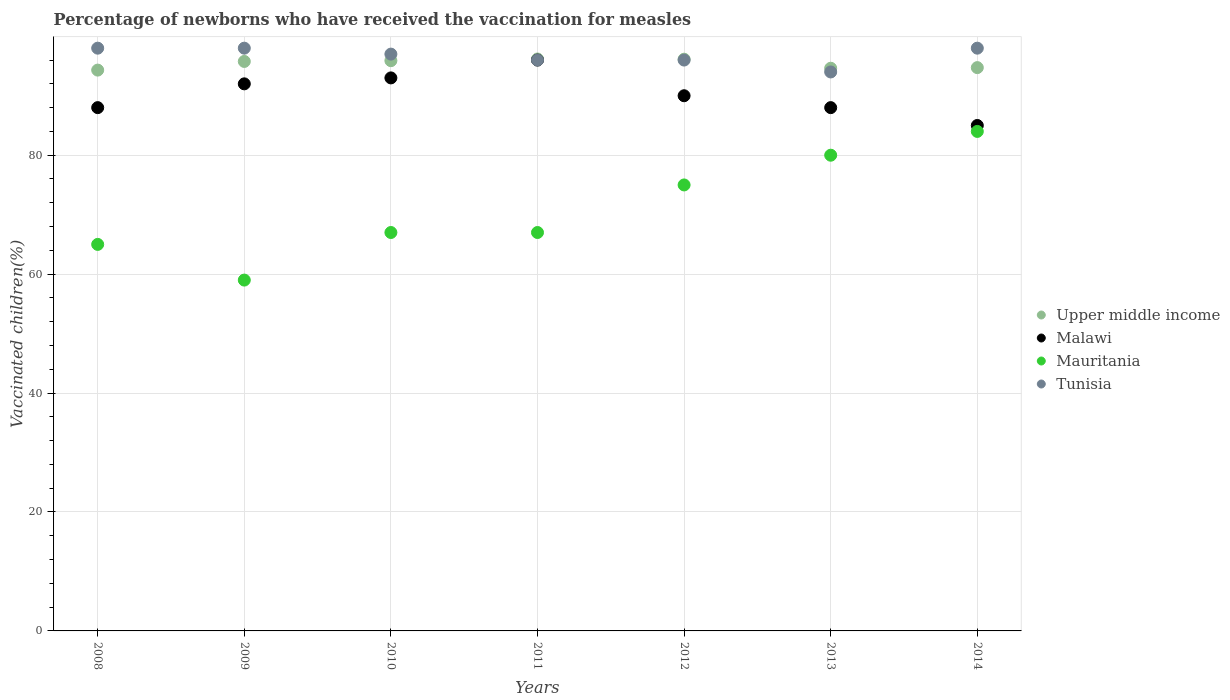Is the number of dotlines equal to the number of legend labels?
Your response must be concise. Yes. Across all years, what is the maximum percentage of vaccinated children in Upper middle income?
Give a very brief answer. 96.18. Across all years, what is the minimum percentage of vaccinated children in Tunisia?
Provide a succinct answer. 94. In which year was the percentage of vaccinated children in Upper middle income maximum?
Your answer should be compact. 2011. In which year was the percentage of vaccinated children in Malawi minimum?
Keep it short and to the point. 2014. What is the total percentage of vaccinated children in Malawi in the graph?
Give a very brief answer. 632. What is the difference between the percentage of vaccinated children in Upper middle income in 2011 and the percentage of vaccinated children in Tunisia in 2010?
Offer a terse response. -0.82. What is the average percentage of vaccinated children in Upper middle income per year?
Your response must be concise. 95.38. In the year 2012, what is the difference between the percentage of vaccinated children in Mauritania and percentage of vaccinated children in Upper middle income?
Provide a short and direct response. -21.15. What is the ratio of the percentage of vaccinated children in Malawi in 2011 to that in 2012?
Give a very brief answer. 1.07. Is the difference between the percentage of vaccinated children in Mauritania in 2008 and 2011 greater than the difference between the percentage of vaccinated children in Upper middle income in 2008 and 2011?
Your response must be concise. No. What is the difference between the highest and the second highest percentage of vaccinated children in Mauritania?
Your response must be concise. 4. What is the difference between the highest and the lowest percentage of vaccinated children in Malawi?
Offer a very short reply. 11. Is the sum of the percentage of vaccinated children in Upper middle income in 2011 and 2012 greater than the maximum percentage of vaccinated children in Malawi across all years?
Keep it short and to the point. Yes. Is it the case that in every year, the sum of the percentage of vaccinated children in Upper middle income and percentage of vaccinated children in Malawi  is greater than the percentage of vaccinated children in Mauritania?
Provide a succinct answer. Yes. Is the percentage of vaccinated children in Tunisia strictly greater than the percentage of vaccinated children in Upper middle income over the years?
Give a very brief answer. No. Is the percentage of vaccinated children in Malawi strictly less than the percentage of vaccinated children in Upper middle income over the years?
Give a very brief answer. Yes. How many years are there in the graph?
Your answer should be very brief. 7. Does the graph contain any zero values?
Your answer should be compact. No. Where does the legend appear in the graph?
Make the answer very short. Center right. How many legend labels are there?
Provide a succinct answer. 4. How are the legend labels stacked?
Provide a succinct answer. Vertical. What is the title of the graph?
Your answer should be very brief. Percentage of newborns who have received the vaccination for measles. What is the label or title of the X-axis?
Offer a terse response. Years. What is the label or title of the Y-axis?
Offer a terse response. Vaccinated children(%). What is the Vaccinated children(%) in Upper middle income in 2008?
Your response must be concise. 94.31. What is the Vaccinated children(%) of Malawi in 2008?
Provide a succinct answer. 88. What is the Vaccinated children(%) in Tunisia in 2008?
Your answer should be compact. 98. What is the Vaccinated children(%) in Upper middle income in 2009?
Your response must be concise. 95.77. What is the Vaccinated children(%) of Malawi in 2009?
Your answer should be very brief. 92. What is the Vaccinated children(%) in Mauritania in 2009?
Keep it short and to the point. 59. What is the Vaccinated children(%) of Upper middle income in 2010?
Keep it short and to the point. 95.9. What is the Vaccinated children(%) of Malawi in 2010?
Ensure brevity in your answer.  93. What is the Vaccinated children(%) of Mauritania in 2010?
Offer a terse response. 67. What is the Vaccinated children(%) of Tunisia in 2010?
Offer a terse response. 97. What is the Vaccinated children(%) in Upper middle income in 2011?
Provide a short and direct response. 96.18. What is the Vaccinated children(%) of Malawi in 2011?
Make the answer very short. 96. What is the Vaccinated children(%) of Tunisia in 2011?
Ensure brevity in your answer.  96. What is the Vaccinated children(%) in Upper middle income in 2012?
Ensure brevity in your answer.  96.15. What is the Vaccinated children(%) in Malawi in 2012?
Keep it short and to the point. 90. What is the Vaccinated children(%) of Mauritania in 2012?
Offer a very short reply. 75. What is the Vaccinated children(%) in Tunisia in 2012?
Provide a succinct answer. 96. What is the Vaccinated children(%) in Upper middle income in 2013?
Your answer should be compact. 94.63. What is the Vaccinated children(%) of Malawi in 2013?
Your answer should be compact. 88. What is the Vaccinated children(%) of Tunisia in 2013?
Offer a terse response. 94. What is the Vaccinated children(%) in Upper middle income in 2014?
Keep it short and to the point. 94.73. What is the Vaccinated children(%) in Malawi in 2014?
Provide a short and direct response. 85. Across all years, what is the maximum Vaccinated children(%) in Upper middle income?
Ensure brevity in your answer.  96.18. Across all years, what is the maximum Vaccinated children(%) of Malawi?
Your answer should be very brief. 96. Across all years, what is the maximum Vaccinated children(%) of Mauritania?
Your response must be concise. 84. Across all years, what is the maximum Vaccinated children(%) of Tunisia?
Your answer should be compact. 98. Across all years, what is the minimum Vaccinated children(%) of Upper middle income?
Your answer should be very brief. 94.31. Across all years, what is the minimum Vaccinated children(%) of Mauritania?
Offer a very short reply. 59. Across all years, what is the minimum Vaccinated children(%) in Tunisia?
Provide a succinct answer. 94. What is the total Vaccinated children(%) in Upper middle income in the graph?
Offer a very short reply. 667.66. What is the total Vaccinated children(%) in Malawi in the graph?
Your answer should be compact. 632. What is the total Vaccinated children(%) of Mauritania in the graph?
Provide a succinct answer. 497. What is the total Vaccinated children(%) in Tunisia in the graph?
Make the answer very short. 677. What is the difference between the Vaccinated children(%) of Upper middle income in 2008 and that in 2009?
Offer a very short reply. -1.46. What is the difference between the Vaccinated children(%) of Malawi in 2008 and that in 2009?
Provide a short and direct response. -4. What is the difference between the Vaccinated children(%) of Tunisia in 2008 and that in 2009?
Keep it short and to the point. 0. What is the difference between the Vaccinated children(%) in Upper middle income in 2008 and that in 2010?
Make the answer very short. -1.58. What is the difference between the Vaccinated children(%) of Tunisia in 2008 and that in 2010?
Your answer should be very brief. 1. What is the difference between the Vaccinated children(%) in Upper middle income in 2008 and that in 2011?
Ensure brevity in your answer.  -1.87. What is the difference between the Vaccinated children(%) of Malawi in 2008 and that in 2011?
Your answer should be compact. -8. What is the difference between the Vaccinated children(%) of Upper middle income in 2008 and that in 2012?
Offer a terse response. -1.83. What is the difference between the Vaccinated children(%) of Upper middle income in 2008 and that in 2013?
Ensure brevity in your answer.  -0.31. What is the difference between the Vaccinated children(%) of Malawi in 2008 and that in 2013?
Keep it short and to the point. 0. What is the difference between the Vaccinated children(%) in Mauritania in 2008 and that in 2013?
Offer a very short reply. -15. What is the difference between the Vaccinated children(%) in Upper middle income in 2008 and that in 2014?
Keep it short and to the point. -0.42. What is the difference between the Vaccinated children(%) of Malawi in 2008 and that in 2014?
Your answer should be compact. 3. What is the difference between the Vaccinated children(%) of Tunisia in 2008 and that in 2014?
Make the answer very short. 0. What is the difference between the Vaccinated children(%) in Upper middle income in 2009 and that in 2010?
Give a very brief answer. -0.13. What is the difference between the Vaccinated children(%) in Malawi in 2009 and that in 2010?
Provide a short and direct response. -1. What is the difference between the Vaccinated children(%) of Mauritania in 2009 and that in 2010?
Your response must be concise. -8. What is the difference between the Vaccinated children(%) in Tunisia in 2009 and that in 2010?
Provide a succinct answer. 1. What is the difference between the Vaccinated children(%) of Upper middle income in 2009 and that in 2011?
Offer a terse response. -0.41. What is the difference between the Vaccinated children(%) in Mauritania in 2009 and that in 2011?
Provide a succinct answer. -8. What is the difference between the Vaccinated children(%) of Tunisia in 2009 and that in 2011?
Ensure brevity in your answer.  2. What is the difference between the Vaccinated children(%) of Upper middle income in 2009 and that in 2012?
Offer a terse response. -0.38. What is the difference between the Vaccinated children(%) in Tunisia in 2009 and that in 2012?
Offer a terse response. 2. What is the difference between the Vaccinated children(%) of Upper middle income in 2009 and that in 2013?
Your answer should be very brief. 1.14. What is the difference between the Vaccinated children(%) of Malawi in 2009 and that in 2013?
Give a very brief answer. 4. What is the difference between the Vaccinated children(%) in Tunisia in 2009 and that in 2013?
Keep it short and to the point. 4. What is the difference between the Vaccinated children(%) in Upper middle income in 2009 and that in 2014?
Keep it short and to the point. 1.04. What is the difference between the Vaccinated children(%) of Malawi in 2009 and that in 2014?
Your response must be concise. 7. What is the difference between the Vaccinated children(%) of Mauritania in 2009 and that in 2014?
Give a very brief answer. -25. What is the difference between the Vaccinated children(%) in Upper middle income in 2010 and that in 2011?
Make the answer very short. -0.28. What is the difference between the Vaccinated children(%) of Malawi in 2010 and that in 2011?
Offer a very short reply. -3. What is the difference between the Vaccinated children(%) in Mauritania in 2010 and that in 2011?
Ensure brevity in your answer.  0. What is the difference between the Vaccinated children(%) of Upper middle income in 2010 and that in 2012?
Provide a short and direct response. -0.25. What is the difference between the Vaccinated children(%) in Malawi in 2010 and that in 2012?
Offer a terse response. 3. What is the difference between the Vaccinated children(%) in Upper middle income in 2010 and that in 2013?
Offer a terse response. 1.27. What is the difference between the Vaccinated children(%) of Tunisia in 2010 and that in 2013?
Your response must be concise. 3. What is the difference between the Vaccinated children(%) in Upper middle income in 2010 and that in 2014?
Ensure brevity in your answer.  1.17. What is the difference between the Vaccinated children(%) of Malawi in 2010 and that in 2014?
Offer a terse response. 8. What is the difference between the Vaccinated children(%) in Mauritania in 2010 and that in 2014?
Keep it short and to the point. -17. What is the difference between the Vaccinated children(%) of Tunisia in 2010 and that in 2014?
Provide a short and direct response. -1. What is the difference between the Vaccinated children(%) of Upper middle income in 2011 and that in 2012?
Ensure brevity in your answer.  0.03. What is the difference between the Vaccinated children(%) of Malawi in 2011 and that in 2012?
Offer a very short reply. 6. What is the difference between the Vaccinated children(%) of Upper middle income in 2011 and that in 2013?
Give a very brief answer. 1.55. What is the difference between the Vaccinated children(%) in Mauritania in 2011 and that in 2013?
Your answer should be very brief. -13. What is the difference between the Vaccinated children(%) of Upper middle income in 2011 and that in 2014?
Offer a terse response. 1.45. What is the difference between the Vaccinated children(%) of Malawi in 2011 and that in 2014?
Offer a very short reply. 11. What is the difference between the Vaccinated children(%) in Mauritania in 2011 and that in 2014?
Your answer should be compact. -17. What is the difference between the Vaccinated children(%) of Tunisia in 2011 and that in 2014?
Your answer should be compact. -2. What is the difference between the Vaccinated children(%) in Upper middle income in 2012 and that in 2013?
Provide a short and direct response. 1.52. What is the difference between the Vaccinated children(%) of Malawi in 2012 and that in 2013?
Provide a short and direct response. 2. What is the difference between the Vaccinated children(%) of Mauritania in 2012 and that in 2013?
Keep it short and to the point. -5. What is the difference between the Vaccinated children(%) of Tunisia in 2012 and that in 2013?
Offer a terse response. 2. What is the difference between the Vaccinated children(%) of Upper middle income in 2012 and that in 2014?
Your answer should be compact. 1.41. What is the difference between the Vaccinated children(%) in Tunisia in 2012 and that in 2014?
Your answer should be compact. -2. What is the difference between the Vaccinated children(%) of Upper middle income in 2013 and that in 2014?
Ensure brevity in your answer.  -0.11. What is the difference between the Vaccinated children(%) of Malawi in 2013 and that in 2014?
Your answer should be very brief. 3. What is the difference between the Vaccinated children(%) of Mauritania in 2013 and that in 2014?
Ensure brevity in your answer.  -4. What is the difference between the Vaccinated children(%) in Upper middle income in 2008 and the Vaccinated children(%) in Malawi in 2009?
Offer a very short reply. 2.31. What is the difference between the Vaccinated children(%) in Upper middle income in 2008 and the Vaccinated children(%) in Mauritania in 2009?
Provide a succinct answer. 35.31. What is the difference between the Vaccinated children(%) in Upper middle income in 2008 and the Vaccinated children(%) in Tunisia in 2009?
Provide a succinct answer. -3.69. What is the difference between the Vaccinated children(%) in Malawi in 2008 and the Vaccinated children(%) in Tunisia in 2009?
Make the answer very short. -10. What is the difference between the Vaccinated children(%) in Mauritania in 2008 and the Vaccinated children(%) in Tunisia in 2009?
Keep it short and to the point. -33. What is the difference between the Vaccinated children(%) in Upper middle income in 2008 and the Vaccinated children(%) in Malawi in 2010?
Make the answer very short. 1.31. What is the difference between the Vaccinated children(%) of Upper middle income in 2008 and the Vaccinated children(%) of Mauritania in 2010?
Your response must be concise. 27.31. What is the difference between the Vaccinated children(%) in Upper middle income in 2008 and the Vaccinated children(%) in Tunisia in 2010?
Your answer should be compact. -2.69. What is the difference between the Vaccinated children(%) of Malawi in 2008 and the Vaccinated children(%) of Mauritania in 2010?
Your answer should be very brief. 21. What is the difference between the Vaccinated children(%) in Mauritania in 2008 and the Vaccinated children(%) in Tunisia in 2010?
Ensure brevity in your answer.  -32. What is the difference between the Vaccinated children(%) of Upper middle income in 2008 and the Vaccinated children(%) of Malawi in 2011?
Your answer should be compact. -1.69. What is the difference between the Vaccinated children(%) of Upper middle income in 2008 and the Vaccinated children(%) of Mauritania in 2011?
Offer a terse response. 27.31. What is the difference between the Vaccinated children(%) of Upper middle income in 2008 and the Vaccinated children(%) of Tunisia in 2011?
Ensure brevity in your answer.  -1.69. What is the difference between the Vaccinated children(%) of Malawi in 2008 and the Vaccinated children(%) of Mauritania in 2011?
Your response must be concise. 21. What is the difference between the Vaccinated children(%) of Malawi in 2008 and the Vaccinated children(%) of Tunisia in 2011?
Provide a succinct answer. -8. What is the difference between the Vaccinated children(%) of Mauritania in 2008 and the Vaccinated children(%) of Tunisia in 2011?
Your answer should be very brief. -31. What is the difference between the Vaccinated children(%) of Upper middle income in 2008 and the Vaccinated children(%) of Malawi in 2012?
Keep it short and to the point. 4.31. What is the difference between the Vaccinated children(%) of Upper middle income in 2008 and the Vaccinated children(%) of Mauritania in 2012?
Ensure brevity in your answer.  19.31. What is the difference between the Vaccinated children(%) of Upper middle income in 2008 and the Vaccinated children(%) of Tunisia in 2012?
Provide a short and direct response. -1.69. What is the difference between the Vaccinated children(%) of Malawi in 2008 and the Vaccinated children(%) of Mauritania in 2012?
Offer a terse response. 13. What is the difference between the Vaccinated children(%) of Mauritania in 2008 and the Vaccinated children(%) of Tunisia in 2012?
Provide a succinct answer. -31. What is the difference between the Vaccinated children(%) in Upper middle income in 2008 and the Vaccinated children(%) in Malawi in 2013?
Your answer should be very brief. 6.31. What is the difference between the Vaccinated children(%) in Upper middle income in 2008 and the Vaccinated children(%) in Mauritania in 2013?
Offer a terse response. 14.31. What is the difference between the Vaccinated children(%) of Upper middle income in 2008 and the Vaccinated children(%) of Tunisia in 2013?
Make the answer very short. 0.31. What is the difference between the Vaccinated children(%) of Malawi in 2008 and the Vaccinated children(%) of Mauritania in 2013?
Provide a short and direct response. 8. What is the difference between the Vaccinated children(%) in Malawi in 2008 and the Vaccinated children(%) in Tunisia in 2013?
Your answer should be very brief. -6. What is the difference between the Vaccinated children(%) of Upper middle income in 2008 and the Vaccinated children(%) of Malawi in 2014?
Keep it short and to the point. 9.31. What is the difference between the Vaccinated children(%) in Upper middle income in 2008 and the Vaccinated children(%) in Mauritania in 2014?
Keep it short and to the point. 10.31. What is the difference between the Vaccinated children(%) of Upper middle income in 2008 and the Vaccinated children(%) of Tunisia in 2014?
Make the answer very short. -3.69. What is the difference between the Vaccinated children(%) in Malawi in 2008 and the Vaccinated children(%) in Tunisia in 2014?
Provide a short and direct response. -10. What is the difference between the Vaccinated children(%) in Mauritania in 2008 and the Vaccinated children(%) in Tunisia in 2014?
Keep it short and to the point. -33. What is the difference between the Vaccinated children(%) of Upper middle income in 2009 and the Vaccinated children(%) of Malawi in 2010?
Your response must be concise. 2.77. What is the difference between the Vaccinated children(%) in Upper middle income in 2009 and the Vaccinated children(%) in Mauritania in 2010?
Ensure brevity in your answer.  28.77. What is the difference between the Vaccinated children(%) of Upper middle income in 2009 and the Vaccinated children(%) of Tunisia in 2010?
Make the answer very short. -1.23. What is the difference between the Vaccinated children(%) in Mauritania in 2009 and the Vaccinated children(%) in Tunisia in 2010?
Provide a short and direct response. -38. What is the difference between the Vaccinated children(%) of Upper middle income in 2009 and the Vaccinated children(%) of Malawi in 2011?
Provide a short and direct response. -0.23. What is the difference between the Vaccinated children(%) in Upper middle income in 2009 and the Vaccinated children(%) in Mauritania in 2011?
Make the answer very short. 28.77. What is the difference between the Vaccinated children(%) of Upper middle income in 2009 and the Vaccinated children(%) of Tunisia in 2011?
Provide a succinct answer. -0.23. What is the difference between the Vaccinated children(%) of Malawi in 2009 and the Vaccinated children(%) of Mauritania in 2011?
Keep it short and to the point. 25. What is the difference between the Vaccinated children(%) in Malawi in 2009 and the Vaccinated children(%) in Tunisia in 2011?
Provide a succinct answer. -4. What is the difference between the Vaccinated children(%) in Mauritania in 2009 and the Vaccinated children(%) in Tunisia in 2011?
Offer a terse response. -37. What is the difference between the Vaccinated children(%) of Upper middle income in 2009 and the Vaccinated children(%) of Malawi in 2012?
Offer a very short reply. 5.77. What is the difference between the Vaccinated children(%) in Upper middle income in 2009 and the Vaccinated children(%) in Mauritania in 2012?
Provide a succinct answer. 20.77. What is the difference between the Vaccinated children(%) in Upper middle income in 2009 and the Vaccinated children(%) in Tunisia in 2012?
Your answer should be very brief. -0.23. What is the difference between the Vaccinated children(%) in Malawi in 2009 and the Vaccinated children(%) in Mauritania in 2012?
Your answer should be compact. 17. What is the difference between the Vaccinated children(%) of Mauritania in 2009 and the Vaccinated children(%) of Tunisia in 2012?
Your answer should be compact. -37. What is the difference between the Vaccinated children(%) in Upper middle income in 2009 and the Vaccinated children(%) in Malawi in 2013?
Your answer should be compact. 7.77. What is the difference between the Vaccinated children(%) of Upper middle income in 2009 and the Vaccinated children(%) of Mauritania in 2013?
Keep it short and to the point. 15.77. What is the difference between the Vaccinated children(%) in Upper middle income in 2009 and the Vaccinated children(%) in Tunisia in 2013?
Ensure brevity in your answer.  1.77. What is the difference between the Vaccinated children(%) of Malawi in 2009 and the Vaccinated children(%) of Mauritania in 2013?
Ensure brevity in your answer.  12. What is the difference between the Vaccinated children(%) of Malawi in 2009 and the Vaccinated children(%) of Tunisia in 2013?
Offer a very short reply. -2. What is the difference between the Vaccinated children(%) of Mauritania in 2009 and the Vaccinated children(%) of Tunisia in 2013?
Offer a very short reply. -35. What is the difference between the Vaccinated children(%) in Upper middle income in 2009 and the Vaccinated children(%) in Malawi in 2014?
Your response must be concise. 10.77. What is the difference between the Vaccinated children(%) of Upper middle income in 2009 and the Vaccinated children(%) of Mauritania in 2014?
Provide a short and direct response. 11.77. What is the difference between the Vaccinated children(%) in Upper middle income in 2009 and the Vaccinated children(%) in Tunisia in 2014?
Your response must be concise. -2.23. What is the difference between the Vaccinated children(%) in Malawi in 2009 and the Vaccinated children(%) in Tunisia in 2014?
Keep it short and to the point. -6. What is the difference between the Vaccinated children(%) of Mauritania in 2009 and the Vaccinated children(%) of Tunisia in 2014?
Make the answer very short. -39. What is the difference between the Vaccinated children(%) in Upper middle income in 2010 and the Vaccinated children(%) in Malawi in 2011?
Offer a very short reply. -0.1. What is the difference between the Vaccinated children(%) in Upper middle income in 2010 and the Vaccinated children(%) in Mauritania in 2011?
Your response must be concise. 28.9. What is the difference between the Vaccinated children(%) of Upper middle income in 2010 and the Vaccinated children(%) of Tunisia in 2011?
Offer a very short reply. -0.1. What is the difference between the Vaccinated children(%) in Upper middle income in 2010 and the Vaccinated children(%) in Malawi in 2012?
Your response must be concise. 5.9. What is the difference between the Vaccinated children(%) of Upper middle income in 2010 and the Vaccinated children(%) of Mauritania in 2012?
Your answer should be compact. 20.9. What is the difference between the Vaccinated children(%) in Upper middle income in 2010 and the Vaccinated children(%) in Tunisia in 2012?
Make the answer very short. -0.1. What is the difference between the Vaccinated children(%) of Malawi in 2010 and the Vaccinated children(%) of Tunisia in 2012?
Your response must be concise. -3. What is the difference between the Vaccinated children(%) of Mauritania in 2010 and the Vaccinated children(%) of Tunisia in 2012?
Keep it short and to the point. -29. What is the difference between the Vaccinated children(%) in Upper middle income in 2010 and the Vaccinated children(%) in Malawi in 2013?
Give a very brief answer. 7.9. What is the difference between the Vaccinated children(%) in Upper middle income in 2010 and the Vaccinated children(%) in Mauritania in 2013?
Ensure brevity in your answer.  15.9. What is the difference between the Vaccinated children(%) in Upper middle income in 2010 and the Vaccinated children(%) in Tunisia in 2013?
Offer a terse response. 1.9. What is the difference between the Vaccinated children(%) in Malawi in 2010 and the Vaccinated children(%) in Mauritania in 2013?
Offer a terse response. 13. What is the difference between the Vaccinated children(%) in Upper middle income in 2010 and the Vaccinated children(%) in Malawi in 2014?
Your answer should be compact. 10.9. What is the difference between the Vaccinated children(%) in Upper middle income in 2010 and the Vaccinated children(%) in Mauritania in 2014?
Provide a short and direct response. 11.9. What is the difference between the Vaccinated children(%) of Upper middle income in 2010 and the Vaccinated children(%) of Tunisia in 2014?
Provide a short and direct response. -2.1. What is the difference between the Vaccinated children(%) of Malawi in 2010 and the Vaccinated children(%) of Tunisia in 2014?
Make the answer very short. -5. What is the difference between the Vaccinated children(%) of Mauritania in 2010 and the Vaccinated children(%) of Tunisia in 2014?
Provide a succinct answer. -31. What is the difference between the Vaccinated children(%) of Upper middle income in 2011 and the Vaccinated children(%) of Malawi in 2012?
Make the answer very short. 6.18. What is the difference between the Vaccinated children(%) in Upper middle income in 2011 and the Vaccinated children(%) in Mauritania in 2012?
Your answer should be compact. 21.18. What is the difference between the Vaccinated children(%) of Upper middle income in 2011 and the Vaccinated children(%) of Tunisia in 2012?
Your answer should be compact. 0.18. What is the difference between the Vaccinated children(%) of Malawi in 2011 and the Vaccinated children(%) of Mauritania in 2012?
Your answer should be very brief. 21. What is the difference between the Vaccinated children(%) of Malawi in 2011 and the Vaccinated children(%) of Tunisia in 2012?
Offer a terse response. 0. What is the difference between the Vaccinated children(%) in Mauritania in 2011 and the Vaccinated children(%) in Tunisia in 2012?
Your answer should be compact. -29. What is the difference between the Vaccinated children(%) of Upper middle income in 2011 and the Vaccinated children(%) of Malawi in 2013?
Provide a succinct answer. 8.18. What is the difference between the Vaccinated children(%) of Upper middle income in 2011 and the Vaccinated children(%) of Mauritania in 2013?
Keep it short and to the point. 16.18. What is the difference between the Vaccinated children(%) of Upper middle income in 2011 and the Vaccinated children(%) of Tunisia in 2013?
Your answer should be compact. 2.18. What is the difference between the Vaccinated children(%) of Malawi in 2011 and the Vaccinated children(%) of Mauritania in 2013?
Offer a terse response. 16. What is the difference between the Vaccinated children(%) of Mauritania in 2011 and the Vaccinated children(%) of Tunisia in 2013?
Your response must be concise. -27. What is the difference between the Vaccinated children(%) of Upper middle income in 2011 and the Vaccinated children(%) of Malawi in 2014?
Make the answer very short. 11.18. What is the difference between the Vaccinated children(%) in Upper middle income in 2011 and the Vaccinated children(%) in Mauritania in 2014?
Your response must be concise. 12.18. What is the difference between the Vaccinated children(%) in Upper middle income in 2011 and the Vaccinated children(%) in Tunisia in 2014?
Make the answer very short. -1.82. What is the difference between the Vaccinated children(%) in Malawi in 2011 and the Vaccinated children(%) in Tunisia in 2014?
Keep it short and to the point. -2. What is the difference between the Vaccinated children(%) in Mauritania in 2011 and the Vaccinated children(%) in Tunisia in 2014?
Keep it short and to the point. -31. What is the difference between the Vaccinated children(%) in Upper middle income in 2012 and the Vaccinated children(%) in Malawi in 2013?
Keep it short and to the point. 8.15. What is the difference between the Vaccinated children(%) in Upper middle income in 2012 and the Vaccinated children(%) in Mauritania in 2013?
Offer a very short reply. 16.15. What is the difference between the Vaccinated children(%) in Upper middle income in 2012 and the Vaccinated children(%) in Tunisia in 2013?
Your answer should be very brief. 2.15. What is the difference between the Vaccinated children(%) in Malawi in 2012 and the Vaccinated children(%) in Mauritania in 2013?
Ensure brevity in your answer.  10. What is the difference between the Vaccinated children(%) in Upper middle income in 2012 and the Vaccinated children(%) in Malawi in 2014?
Make the answer very short. 11.15. What is the difference between the Vaccinated children(%) in Upper middle income in 2012 and the Vaccinated children(%) in Mauritania in 2014?
Provide a succinct answer. 12.15. What is the difference between the Vaccinated children(%) of Upper middle income in 2012 and the Vaccinated children(%) of Tunisia in 2014?
Provide a short and direct response. -1.85. What is the difference between the Vaccinated children(%) of Malawi in 2012 and the Vaccinated children(%) of Tunisia in 2014?
Provide a short and direct response. -8. What is the difference between the Vaccinated children(%) of Mauritania in 2012 and the Vaccinated children(%) of Tunisia in 2014?
Keep it short and to the point. -23. What is the difference between the Vaccinated children(%) in Upper middle income in 2013 and the Vaccinated children(%) in Malawi in 2014?
Your answer should be very brief. 9.63. What is the difference between the Vaccinated children(%) in Upper middle income in 2013 and the Vaccinated children(%) in Mauritania in 2014?
Your answer should be very brief. 10.63. What is the difference between the Vaccinated children(%) of Upper middle income in 2013 and the Vaccinated children(%) of Tunisia in 2014?
Your answer should be compact. -3.37. What is the average Vaccinated children(%) in Upper middle income per year?
Ensure brevity in your answer.  95.38. What is the average Vaccinated children(%) in Malawi per year?
Your answer should be very brief. 90.29. What is the average Vaccinated children(%) of Mauritania per year?
Provide a short and direct response. 71. What is the average Vaccinated children(%) in Tunisia per year?
Your response must be concise. 96.71. In the year 2008, what is the difference between the Vaccinated children(%) of Upper middle income and Vaccinated children(%) of Malawi?
Your answer should be compact. 6.31. In the year 2008, what is the difference between the Vaccinated children(%) of Upper middle income and Vaccinated children(%) of Mauritania?
Offer a very short reply. 29.31. In the year 2008, what is the difference between the Vaccinated children(%) in Upper middle income and Vaccinated children(%) in Tunisia?
Offer a terse response. -3.69. In the year 2008, what is the difference between the Vaccinated children(%) in Malawi and Vaccinated children(%) in Mauritania?
Ensure brevity in your answer.  23. In the year 2008, what is the difference between the Vaccinated children(%) in Malawi and Vaccinated children(%) in Tunisia?
Ensure brevity in your answer.  -10. In the year 2008, what is the difference between the Vaccinated children(%) of Mauritania and Vaccinated children(%) of Tunisia?
Provide a succinct answer. -33. In the year 2009, what is the difference between the Vaccinated children(%) of Upper middle income and Vaccinated children(%) of Malawi?
Your response must be concise. 3.77. In the year 2009, what is the difference between the Vaccinated children(%) of Upper middle income and Vaccinated children(%) of Mauritania?
Your response must be concise. 36.77. In the year 2009, what is the difference between the Vaccinated children(%) in Upper middle income and Vaccinated children(%) in Tunisia?
Your answer should be compact. -2.23. In the year 2009, what is the difference between the Vaccinated children(%) in Malawi and Vaccinated children(%) in Mauritania?
Offer a terse response. 33. In the year 2009, what is the difference between the Vaccinated children(%) in Mauritania and Vaccinated children(%) in Tunisia?
Offer a terse response. -39. In the year 2010, what is the difference between the Vaccinated children(%) of Upper middle income and Vaccinated children(%) of Malawi?
Your response must be concise. 2.9. In the year 2010, what is the difference between the Vaccinated children(%) in Upper middle income and Vaccinated children(%) in Mauritania?
Keep it short and to the point. 28.9. In the year 2010, what is the difference between the Vaccinated children(%) in Upper middle income and Vaccinated children(%) in Tunisia?
Give a very brief answer. -1.1. In the year 2010, what is the difference between the Vaccinated children(%) in Malawi and Vaccinated children(%) in Mauritania?
Offer a very short reply. 26. In the year 2010, what is the difference between the Vaccinated children(%) of Malawi and Vaccinated children(%) of Tunisia?
Offer a very short reply. -4. In the year 2010, what is the difference between the Vaccinated children(%) in Mauritania and Vaccinated children(%) in Tunisia?
Provide a short and direct response. -30. In the year 2011, what is the difference between the Vaccinated children(%) of Upper middle income and Vaccinated children(%) of Malawi?
Your response must be concise. 0.18. In the year 2011, what is the difference between the Vaccinated children(%) in Upper middle income and Vaccinated children(%) in Mauritania?
Your answer should be very brief. 29.18. In the year 2011, what is the difference between the Vaccinated children(%) of Upper middle income and Vaccinated children(%) of Tunisia?
Offer a terse response. 0.18. In the year 2011, what is the difference between the Vaccinated children(%) of Malawi and Vaccinated children(%) of Tunisia?
Provide a short and direct response. 0. In the year 2012, what is the difference between the Vaccinated children(%) of Upper middle income and Vaccinated children(%) of Malawi?
Offer a very short reply. 6.15. In the year 2012, what is the difference between the Vaccinated children(%) in Upper middle income and Vaccinated children(%) in Mauritania?
Keep it short and to the point. 21.15. In the year 2012, what is the difference between the Vaccinated children(%) in Upper middle income and Vaccinated children(%) in Tunisia?
Keep it short and to the point. 0.15. In the year 2012, what is the difference between the Vaccinated children(%) in Mauritania and Vaccinated children(%) in Tunisia?
Your answer should be compact. -21. In the year 2013, what is the difference between the Vaccinated children(%) of Upper middle income and Vaccinated children(%) of Malawi?
Provide a short and direct response. 6.63. In the year 2013, what is the difference between the Vaccinated children(%) in Upper middle income and Vaccinated children(%) in Mauritania?
Your answer should be very brief. 14.63. In the year 2013, what is the difference between the Vaccinated children(%) in Upper middle income and Vaccinated children(%) in Tunisia?
Make the answer very short. 0.63. In the year 2014, what is the difference between the Vaccinated children(%) in Upper middle income and Vaccinated children(%) in Malawi?
Give a very brief answer. 9.73. In the year 2014, what is the difference between the Vaccinated children(%) of Upper middle income and Vaccinated children(%) of Mauritania?
Give a very brief answer. 10.73. In the year 2014, what is the difference between the Vaccinated children(%) of Upper middle income and Vaccinated children(%) of Tunisia?
Provide a succinct answer. -3.27. In the year 2014, what is the difference between the Vaccinated children(%) in Malawi and Vaccinated children(%) in Mauritania?
Provide a succinct answer. 1. In the year 2014, what is the difference between the Vaccinated children(%) of Mauritania and Vaccinated children(%) of Tunisia?
Your response must be concise. -14. What is the ratio of the Vaccinated children(%) of Malawi in 2008 to that in 2009?
Give a very brief answer. 0.96. What is the ratio of the Vaccinated children(%) of Mauritania in 2008 to that in 2009?
Give a very brief answer. 1.1. What is the ratio of the Vaccinated children(%) in Tunisia in 2008 to that in 2009?
Make the answer very short. 1. What is the ratio of the Vaccinated children(%) of Upper middle income in 2008 to that in 2010?
Your answer should be compact. 0.98. What is the ratio of the Vaccinated children(%) in Malawi in 2008 to that in 2010?
Keep it short and to the point. 0.95. What is the ratio of the Vaccinated children(%) of Mauritania in 2008 to that in 2010?
Your response must be concise. 0.97. What is the ratio of the Vaccinated children(%) in Tunisia in 2008 to that in 2010?
Keep it short and to the point. 1.01. What is the ratio of the Vaccinated children(%) of Upper middle income in 2008 to that in 2011?
Your answer should be very brief. 0.98. What is the ratio of the Vaccinated children(%) of Mauritania in 2008 to that in 2011?
Provide a succinct answer. 0.97. What is the ratio of the Vaccinated children(%) in Tunisia in 2008 to that in 2011?
Offer a very short reply. 1.02. What is the ratio of the Vaccinated children(%) of Upper middle income in 2008 to that in 2012?
Give a very brief answer. 0.98. What is the ratio of the Vaccinated children(%) of Malawi in 2008 to that in 2012?
Keep it short and to the point. 0.98. What is the ratio of the Vaccinated children(%) in Mauritania in 2008 to that in 2012?
Give a very brief answer. 0.87. What is the ratio of the Vaccinated children(%) of Tunisia in 2008 to that in 2012?
Your answer should be very brief. 1.02. What is the ratio of the Vaccinated children(%) in Malawi in 2008 to that in 2013?
Offer a very short reply. 1. What is the ratio of the Vaccinated children(%) of Mauritania in 2008 to that in 2013?
Provide a short and direct response. 0.81. What is the ratio of the Vaccinated children(%) of Tunisia in 2008 to that in 2013?
Your answer should be very brief. 1.04. What is the ratio of the Vaccinated children(%) in Malawi in 2008 to that in 2014?
Give a very brief answer. 1.04. What is the ratio of the Vaccinated children(%) in Mauritania in 2008 to that in 2014?
Make the answer very short. 0.77. What is the ratio of the Vaccinated children(%) of Tunisia in 2008 to that in 2014?
Provide a short and direct response. 1. What is the ratio of the Vaccinated children(%) in Mauritania in 2009 to that in 2010?
Provide a short and direct response. 0.88. What is the ratio of the Vaccinated children(%) of Tunisia in 2009 to that in 2010?
Offer a very short reply. 1.01. What is the ratio of the Vaccinated children(%) in Malawi in 2009 to that in 2011?
Give a very brief answer. 0.96. What is the ratio of the Vaccinated children(%) in Mauritania in 2009 to that in 2011?
Offer a very short reply. 0.88. What is the ratio of the Vaccinated children(%) of Tunisia in 2009 to that in 2011?
Keep it short and to the point. 1.02. What is the ratio of the Vaccinated children(%) in Upper middle income in 2009 to that in 2012?
Make the answer very short. 1. What is the ratio of the Vaccinated children(%) in Malawi in 2009 to that in 2012?
Give a very brief answer. 1.02. What is the ratio of the Vaccinated children(%) in Mauritania in 2009 to that in 2012?
Provide a succinct answer. 0.79. What is the ratio of the Vaccinated children(%) in Tunisia in 2009 to that in 2012?
Offer a very short reply. 1.02. What is the ratio of the Vaccinated children(%) in Upper middle income in 2009 to that in 2013?
Provide a short and direct response. 1.01. What is the ratio of the Vaccinated children(%) of Malawi in 2009 to that in 2013?
Your response must be concise. 1.05. What is the ratio of the Vaccinated children(%) of Mauritania in 2009 to that in 2013?
Offer a terse response. 0.74. What is the ratio of the Vaccinated children(%) of Tunisia in 2009 to that in 2013?
Keep it short and to the point. 1.04. What is the ratio of the Vaccinated children(%) of Upper middle income in 2009 to that in 2014?
Your answer should be very brief. 1.01. What is the ratio of the Vaccinated children(%) of Malawi in 2009 to that in 2014?
Offer a very short reply. 1.08. What is the ratio of the Vaccinated children(%) of Mauritania in 2009 to that in 2014?
Provide a short and direct response. 0.7. What is the ratio of the Vaccinated children(%) in Upper middle income in 2010 to that in 2011?
Offer a terse response. 1. What is the ratio of the Vaccinated children(%) of Malawi in 2010 to that in 2011?
Provide a short and direct response. 0.97. What is the ratio of the Vaccinated children(%) of Tunisia in 2010 to that in 2011?
Offer a terse response. 1.01. What is the ratio of the Vaccinated children(%) in Upper middle income in 2010 to that in 2012?
Your response must be concise. 1. What is the ratio of the Vaccinated children(%) of Mauritania in 2010 to that in 2012?
Your response must be concise. 0.89. What is the ratio of the Vaccinated children(%) in Tunisia in 2010 to that in 2012?
Give a very brief answer. 1.01. What is the ratio of the Vaccinated children(%) of Upper middle income in 2010 to that in 2013?
Provide a succinct answer. 1.01. What is the ratio of the Vaccinated children(%) in Malawi in 2010 to that in 2013?
Keep it short and to the point. 1.06. What is the ratio of the Vaccinated children(%) of Mauritania in 2010 to that in 2013?
Provide a short and direct response. 0.84. What is the ratio of the Vaccinated children(%) in Tunisia in 2010 to that in 2013?
Give a very brief answer. 1.03. What is the ratio of the Vaccinated children(%) in Upper middle income in 2010 to that in 2014?
Provide a succinct answer. 1.01. What is the ratio of the Vaccinated children(%) of Malawi in 2010 to that in 2014?
Ensure brevity in your answer.  1.09. What is the ratio of the Vaccinated children(%) in Mauritania in 2010 to that in 2014?
Your answer should be compact. 0.8. What is the ratio of the Vaccinated children(%) in Upper middle income in 2011 to that in 2012?
Give a very brief answer. 1. What is the ratio of the Vaccinated children(%) of Malawi in 2011 to that in 2012?
Offer a very short reply. 1.07. What is the ratio of the Vaccinated children(%) in Mauritania in 2011 to that in 2012?
Make the answer very short. 0.89. What is the ratio of the Vaccinated children(%) in Tunisia in 2011 to that in 2012?
Your response must be concise. 1. What is the ratio of the Vaccinated children(%) in Upper middle income in 2011 to that in 2013?
Provide a succinct answer. 1.02. What is the ratio of the Vaccinated children(%) of Malawi in 2011 to that in 2013?
Your response must be concise. 1.09. What is the ratio of the Vaccinated children(%) in Mauritania in 2011 to that in 2013?
Give a very brief answer. 0.84. What is the ratio of the Vaccinated children(%) in Tunisia in 2011 to that in 2013?
Provide a succinct answer. 1.02. What is the ratio of the Vaccinated children(%) in Upper middle income in 2011 to that in 2014?
Your answer should be compact. 1.02. What is the ratio of the Vaccinated children(%) in Malawi in 2011 to that in 2014?
Provide a short and direct response. 1.13. What is the ratio of the Vaccinated children(%) in Mauritania in 2011 to that in 2014?
Provide a short and direct response. 0.8. What is the ratio of the Vaccinated children(%) of Tunisia in 2011 to that in 2014?
Your answer should be compact. 0.98. What is the ratio of the Vaccinated children(%) in Upper middle income in 2012 to that in 2013?
Your response must be concise. 1.02. What is the ratio of the Vaccinated children(%) of Malawi in 2012 to that in 2013?
Keep it short and to the point. 1.02. What is the ratio of the Vaccinated children(%) in Tunisia in 2012 to that in 2013?
Provide a short and direct response. 1.02. What is the ratio of the Vaccinated children(%) in Upper middle income in 2012 to that in 2014?
Offer a terse response. 1.01. What is the ratio of the Vaccinated children(%) of Malawi in 2012 to that in 2014?
Ensure brevity in your answer.  1.06. What is the ratio of the Vaccinated children(%) of Mauritania in 2012 to that in 2014?
Your answer should be compact. 0.89. What is the ratio of the Vaccinated children(%) in Tunisia in 2012 to that in 2014?
Your response must be concise. 0.98. What is the ratio of the Vaccinated children(%) in Upper middle income in 2013 to that in 2014?
Your answer should be compact. 1. What is the ratio of the Vaccinated children(%) in Malawi in 2013 to that in 2014?
Keep it short and to the point. 1.04. What is the ratio of the Vaccinated children(%) of Tunisia in 2013 to that in 2014?
Your answer should be compact. 0.96. What is the difference between the highest and the second highest Vaccinated children(%) in Upper middle income?
Make the answer very short. 0.03. What is the difference between the highest and the lowest Vaccinated children(%) of Upper middle income?
Ensure brevity in your answer.  1.87. What is the difference between the highest and the lowest Vaccinated children(%) of Mauritania?
Give a very brief answer. 25. What is the difference between the highest and the lowest Vaccinated children(%) of Tunisia?
Give a very brief answer. 4. 